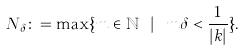Convert formula to latex. <formula><loc_0><loc_0><loc_500><loc_500>N _ { \delta } \colon = \max \{ m \in \mathbb { N } \ | \ m \delta < \frac { 1 } { | k | } \} .</formula> 